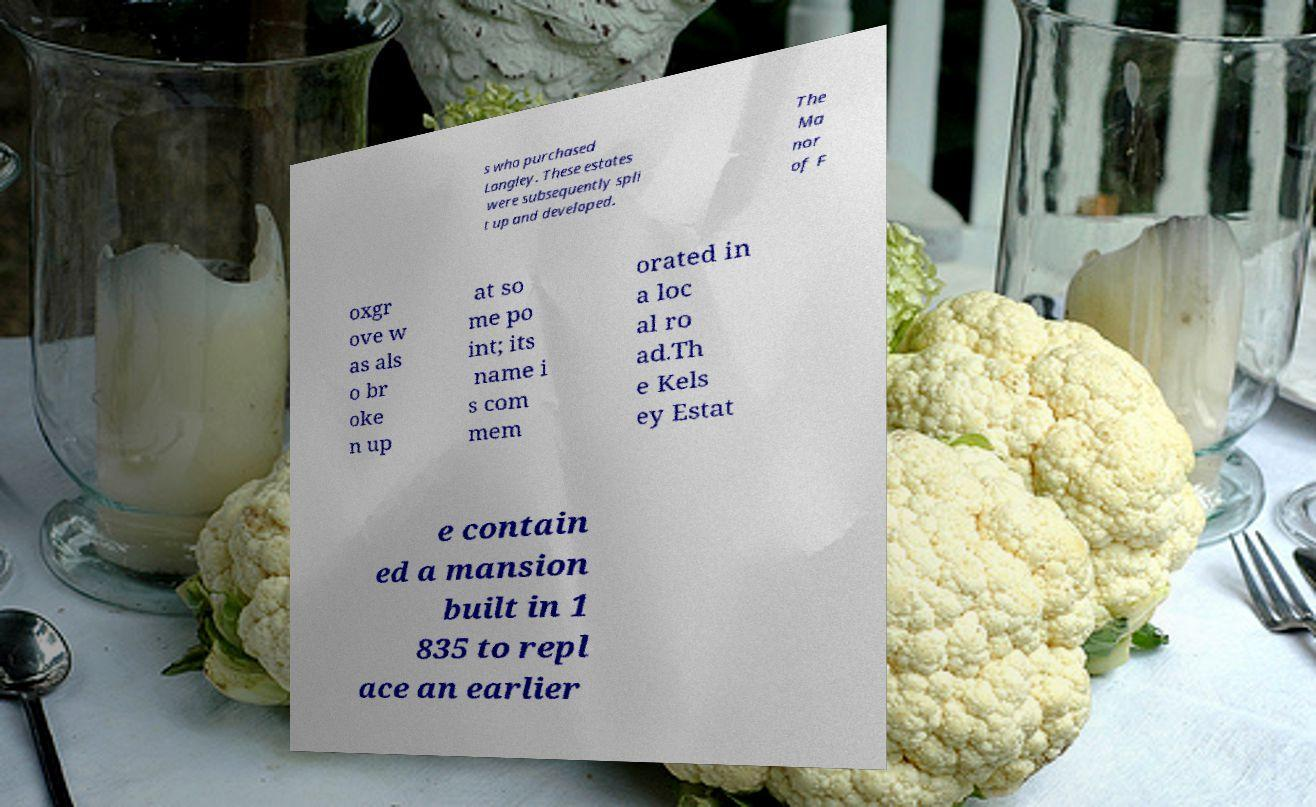Please identify and transcribe the text found in this image. s who purchased Langley. These estates were subsequently spli t up and developed. The Ma nor of F oxgr ove w as als o br oke n up at so me po int; its name i s com mem orated in a loc al ro ad.Th e Kels ey Estat e contain ed a mansion built in 1 835 to repl ace an earlier 